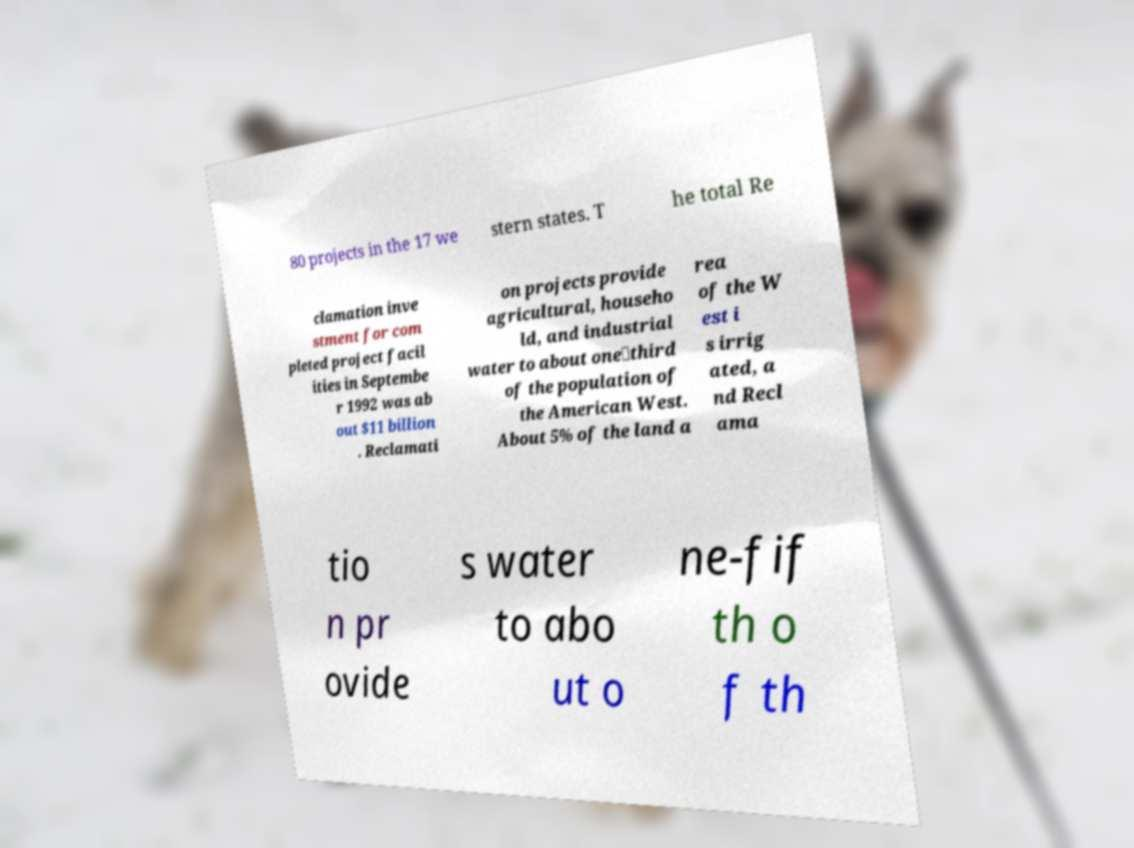I need the written content from this picture converted into text. Can you do that? 80 projects in the 17 we stern states. T he total Re clamation inve stment for com pleted project facil ities in Septembe r 1992 was ab out $11 billion . Reclamati on projects provide agricultural, househo ld, and industrial water to about one‑third of the population of the American West. About 5% of the land a rea of the W est i s irrig ated, a nd Recl ama tio n pr ovide s water to abo ut o ne-fif th o f th 